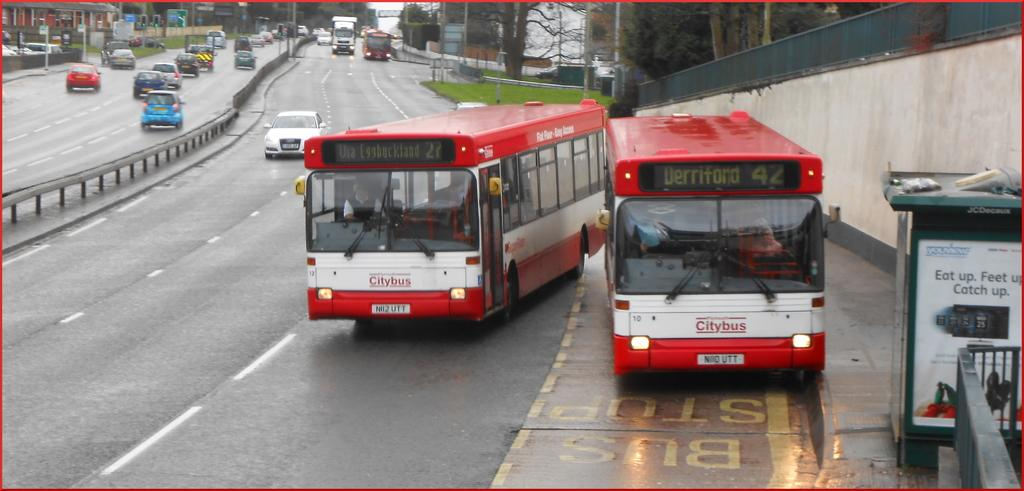What types of objects can be seen in the image? There are vehicles, a fence, roads, a wall, grass, boards, poles, and houses in the image. Can you describe the landscape in the image? The image features roads, grass, and houses, suggesting it might be a suburban or rural area. What is the background of the image? The sky is visible in the background of the image. What structures are present in the image? The image includes a fence, a wall, and houses. How does the wind affect the movement of the spring in the image? There is no spring present in the image, so the wind's effect on it cannot be determined. What type of roll can be seen in the image? There is no roll present in the image. 